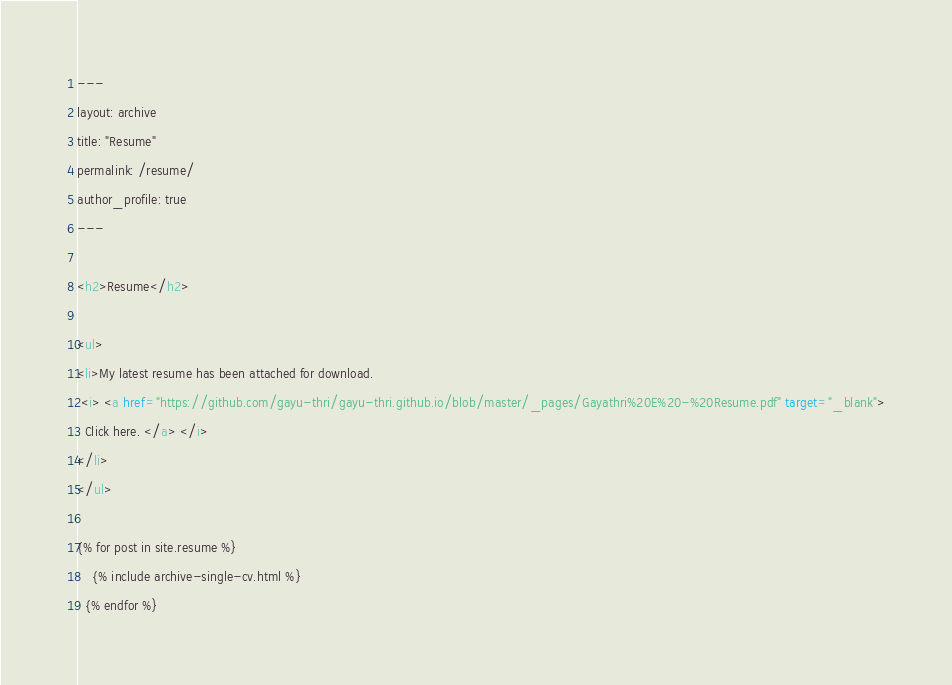Convert code to text. <code><loc_0><loc_0><loc_500><loc_500><_HTML_>---
layout: archive
title: "Resume"
permalink: /resume/
author_profile: true
---

<h2>Resume</h2>

<ul>
<li>My latest resume has been attached for download. 
 <i> <a href="https://github.com/gayu-thri/gayu-thri.github.io/blob/master/_pages/Gayathri%20E%20-%20Resume.pdf" target="_blank">
  Click here. </a> </i>
</li>
</ul>

{% for post in site.resume %}
    {% include archive-single-cv.html %}
  {% endfor %}

</code> 